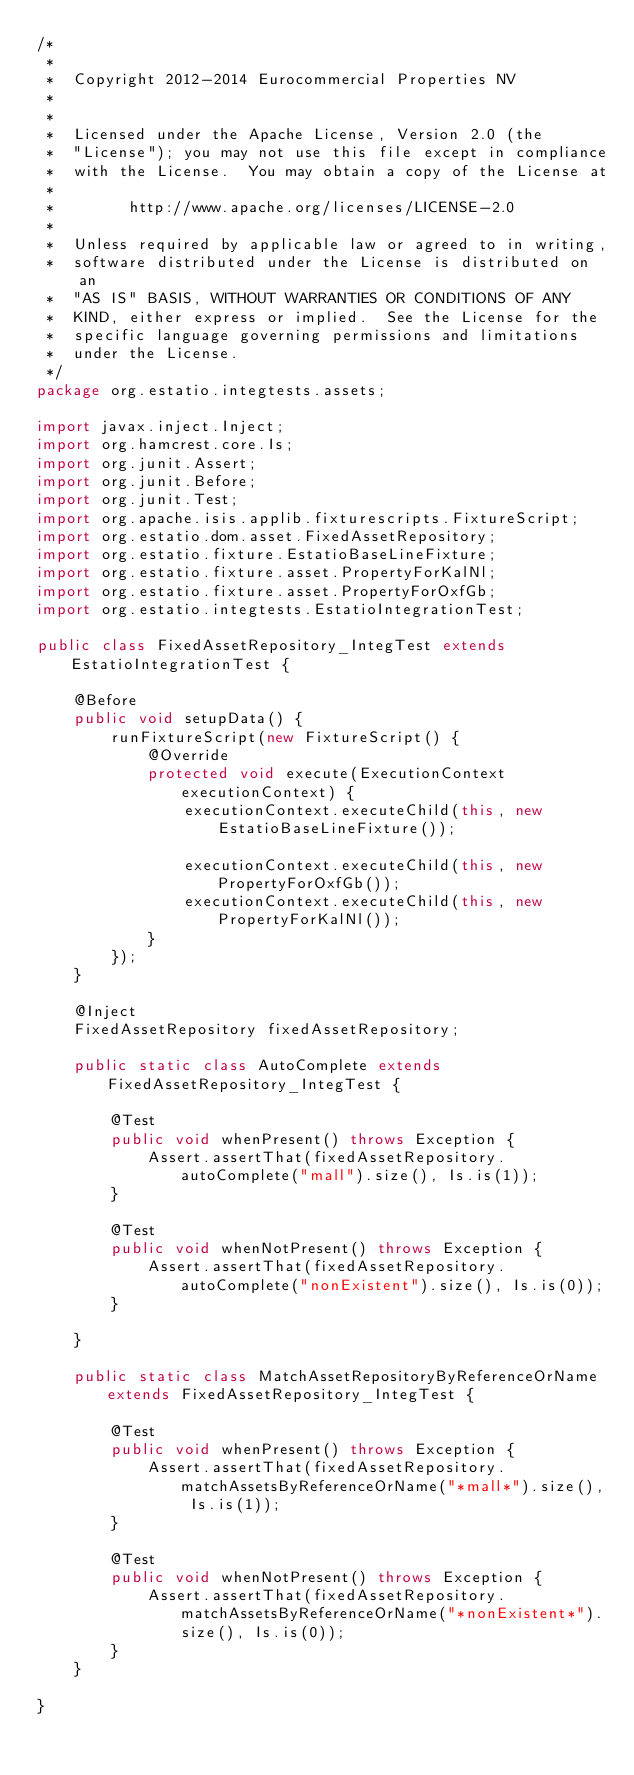Convert code to text. <code><loc_0><loc_0><loc_500><loc_500><_Java_>/*
 *
 *  Copyright 2012-2014 Eurocommercial Properties NV
 *
 *
 *  Licensed under the Apache License, Version 2.0 (the
 *  "License"); you may not use this file except in compliance
 *  with the License.  You may obtain a copy of the License at
 *
 *        http://www.apache.org/licenses/LICENSE-2.0
 *
 *  Unless required by applicable law or agreed to in writing,
 *  software distributed under the License is distributed on an
 *  "AS IS" BASIS, WITHOUT WARRANTIES OR CONDITIONS OF ANY
 *  KIND, either express or implied.  See the License for the
 *  specific language governing permissions and limitations
 *  under the License.
 */
package org.estatio.integtests.assets;

import javax.inject.Inject;
import org.hamcrest.core.Is;
import org.junit.Assert;
import org.junit.Before;
import org.junit.Test;
import org.apache.isis.applib.fixturescripts.FixtureScript;
import org.estatio.dom.asset.FixedAssetRepository;
import org.estatio.fixture.EstatioBaseLineFixture;
import org.estatio.fixture.asset.PropertyForKalNl;
import org.estatio.fixture.asset.PropertyForOxfGb;
import org.estatio.integtests.EstatioIntegrationTest;

public class FixedAssetRepository_IntegTest extends EstatioIntegrationTest {

    @Before
    public void setupData() {
        runFixtureScript(new FixtureScript() {
            @Override
            protected void execute(ExecutionContext executionContext) {
                executionContext.executeChild(this, new EstatioBaseLineFixture());

                executionContext.executeChild(this, new PropertyForOxfGb());
                executionContext.executeChild(this, new PropertyForKalNl());
            }
        });
    }

    @Inject
    FixedAssetRepository fixedAssetRepository;

    public static class AutoComplete extends FixedAssetRepository_IntegTest {

        @Test
        public void whenPresent() throws Exception {
            Assert.assertThat(fixedAssetRepository.autoComplete("mall").size(), Is.is(1));
        }

        @Test
        public void whenNotPresent() throws Exception {
            Assert.assertThat(fixedAssetRepository.autoComplete("nonExistent").size(), Is.is(0));
        }

    }

    public static class MatchAssetRepositoryByReferenceOrName extends FixedAssetRepository_IntegTest {

        @Test
        public void whenPresent() throws Exception {
            Assert.assertThat(fixedAssetRepository.matchAssetsByReferenceOrName("*mall*").size(), Is.is(1));
        }

        @Test
        public void whenNotPresent() throws Exception {
            Assert.assertThat(fixedAssetRepository.matchAssetsByReferenceOrName("*nonExistent*").size(), Is.is(0));
        }
    }

}</code> 